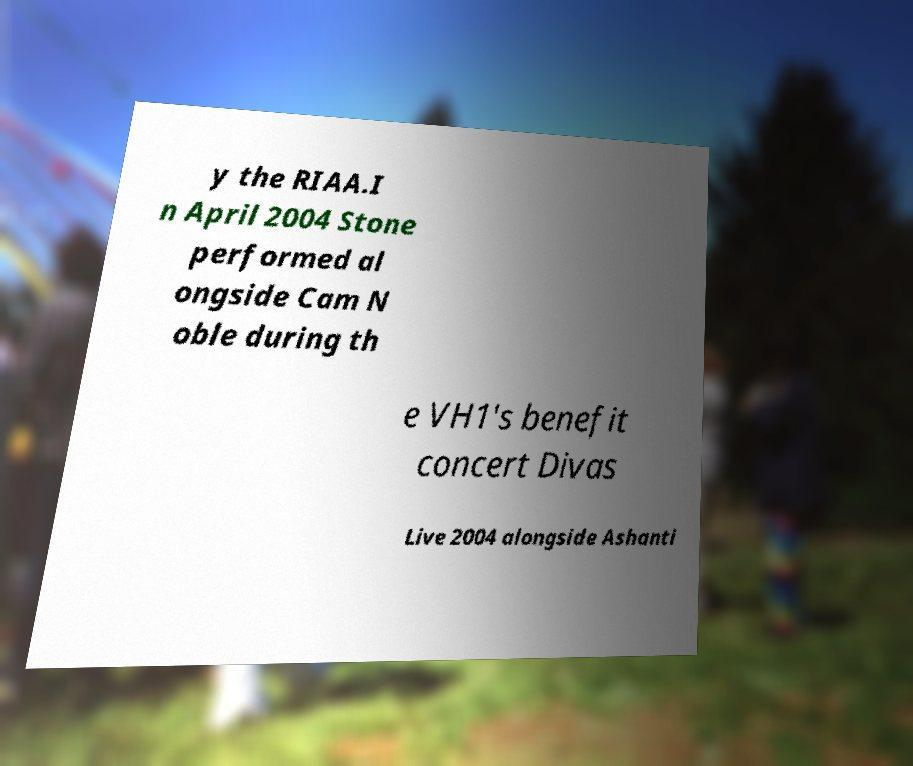For documentation purposes, I need the text within this image transcribed. Could you provide that? y the RIAA.I n April 2004 Stone performed al ongside Cam N oble during th e VH1's benefit concert Divas Live 2004 alongside Ashanti 